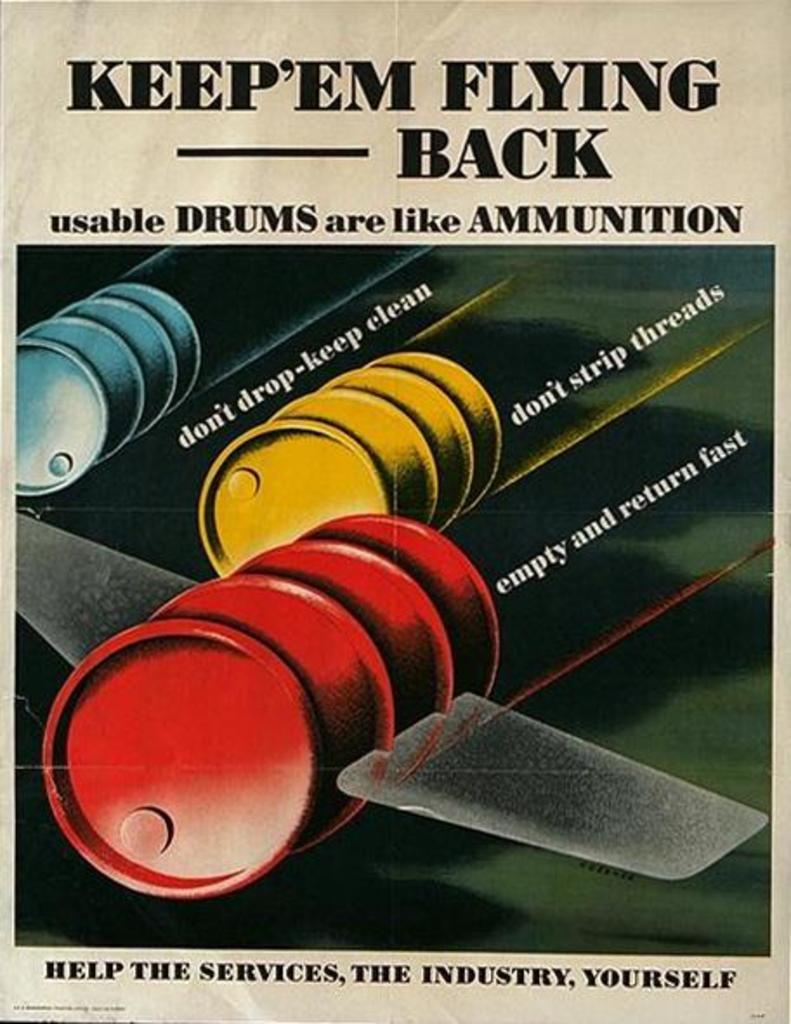<image>
Share a concise interpretation of the image provided. ad showing pictures of drums with wings stating that usable drums are like ammunition 